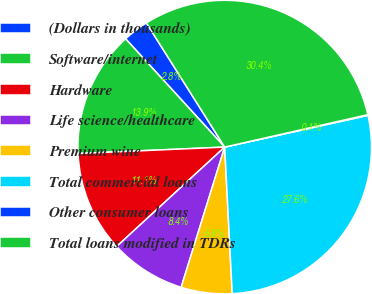Convert chart to OTSL. <chart><loc_0><loc_0><loc_500><loc_500><pie_chart><fcel>(Dollars in thousands)<fcel>Software/internet<fcel>Hardware<fcel>Life science/healthcare<fcel>Premium wine<fcel>Total commercial loans<fcel>Other consumer loans<fcel>Total loans modified in TDRs<nl><fcel>2.84%<fcel>13.9%<fcel>11.14%<fcel>8.37%<fcel>5.61%<fcel>27.65%<fcel>0.08%<fcel>30.41%<nl></chart> 